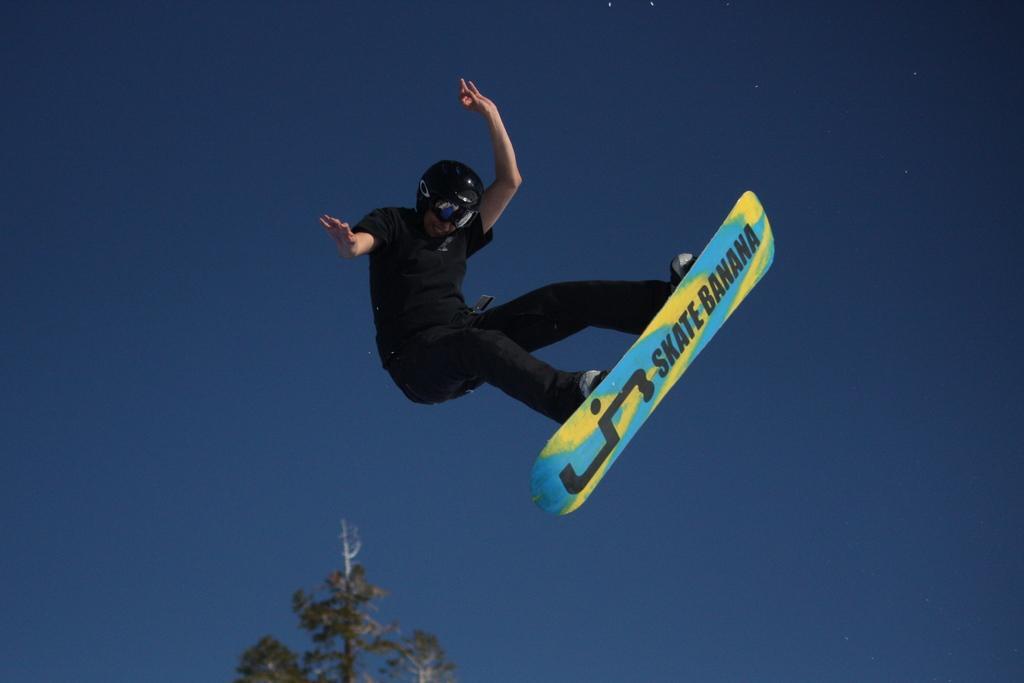Could you give a brief overview of what you see in this image? In this image I can see a person wearing black colored dress and black color helmet is flying in the air and I can see a board to his legs. In the background I can see a tree and the sky. 